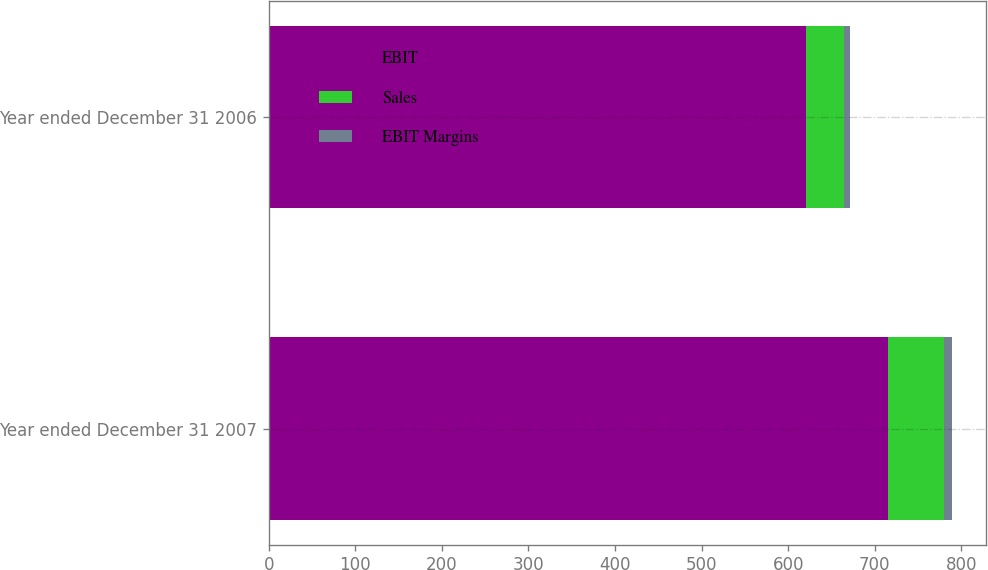Convert chart. <chart><loc_0><loc_0><loc_500><loc_500><stacked_bar_chart><ecel><fcel>Year ended December 31 2007<fcel>Year ended December 31 2006<nl><fcel>EBIT<fcel>715<fcel>621<nl><fcel>Sales<fcel>65<fcel>43<nl><fcel>EBIT Margins<fcel>9.1<fcel>6.9<nl></chart> 